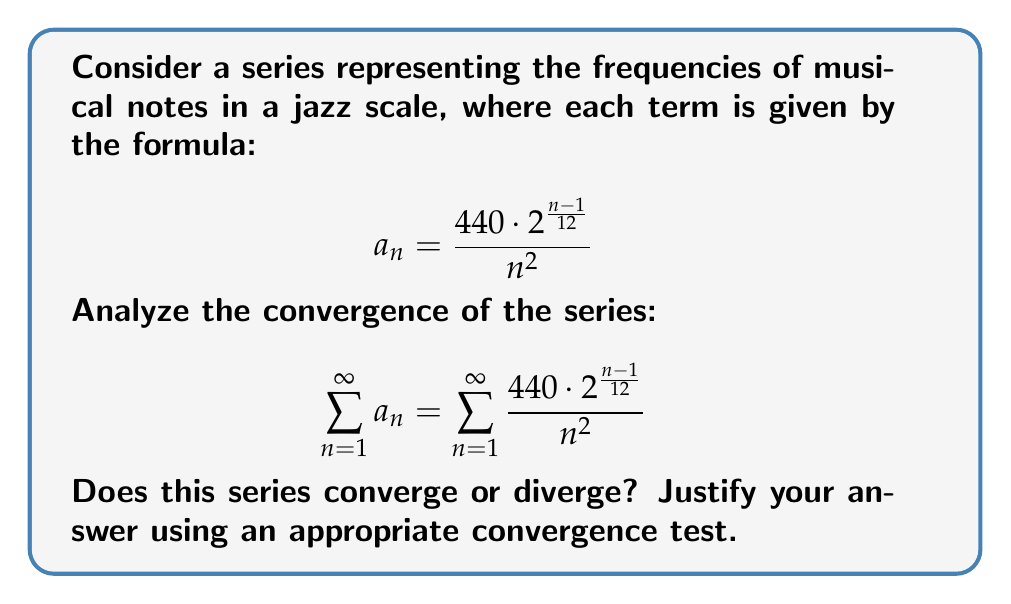Give your solution to this math problem. Let's approach this step-by-step:

1) First, we need to consider the behavior of the general term $a_n$ as $n$ approaches infinity:

   $$\lim_{n \to \infty} a_n = \lim_{n \to \infty} \frac{440 \cdot 2^{\frac{n-1}{12}}}{n^2}$$

2) We can see that the numerator grows exponentially while the denominator grows quadratically. This suggests that the limit of $a_n$ is not 0, which means the series diverges by the divergence test.

3) To prove this rigorously, we can use the ratio test:

   $$\lim_{n \to \infty} \left|\frac{a_{n+1}}{a_n}\right| = \lim_{n \to \infty} \left|\frac{\frac{440 \cdot 2^{\frac{n}{12}}}{(n+1)^2}}{\frac{440 \cdot 2^{\frac{n-1}{12}}}{n^2}}\right|$$

4) Simplifying:

   $$\lim_{n \to \infty} \left|\frac{2^{\frac{1}{12}} \cdot n^2}{(n+1)^2}\right| = 2^{\frac{1}{12}} \cdot \lim_{n \to \infty} \left(\frac{n}{n+1}\right)^2 = 2^{\frac{1}{12}} \approx 1.0595$$

5) Since this limit is greater than 1, the ratio test concludes that the series diverges.

This result makes sense musically, as the frequencies of notes in higher octaves (represented by larger $n$) continue to increase, albeit at a slower rate than the decrease caused by the $\frac{1}{n^2}$ term.
Answer: The series diverges. 